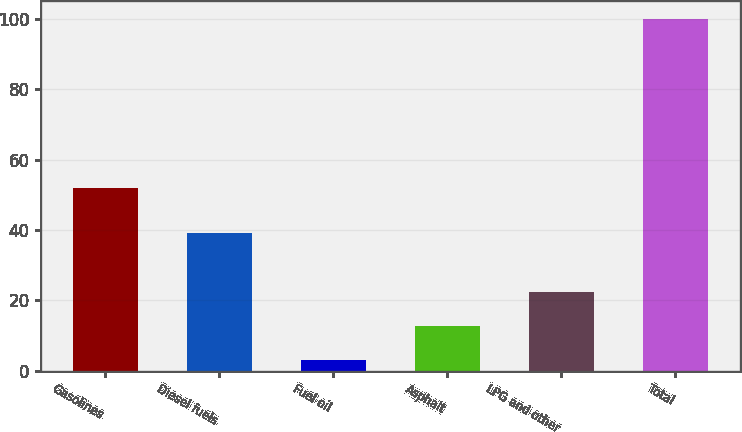Convert chart to OTSL. <chart><loc_0><loc_0><loc_500><loc_500><bar_chart><fcel>Gasolines<fcel>Diesel fuels<fcel>Fuel oil<fcel>Asphalt<fcel>LPG and other<fcel>Total<nl><fcel>52<fcel>39<fcel>3<fcel>12.7<fcel>22.4<fcel>100<nl></chart> 